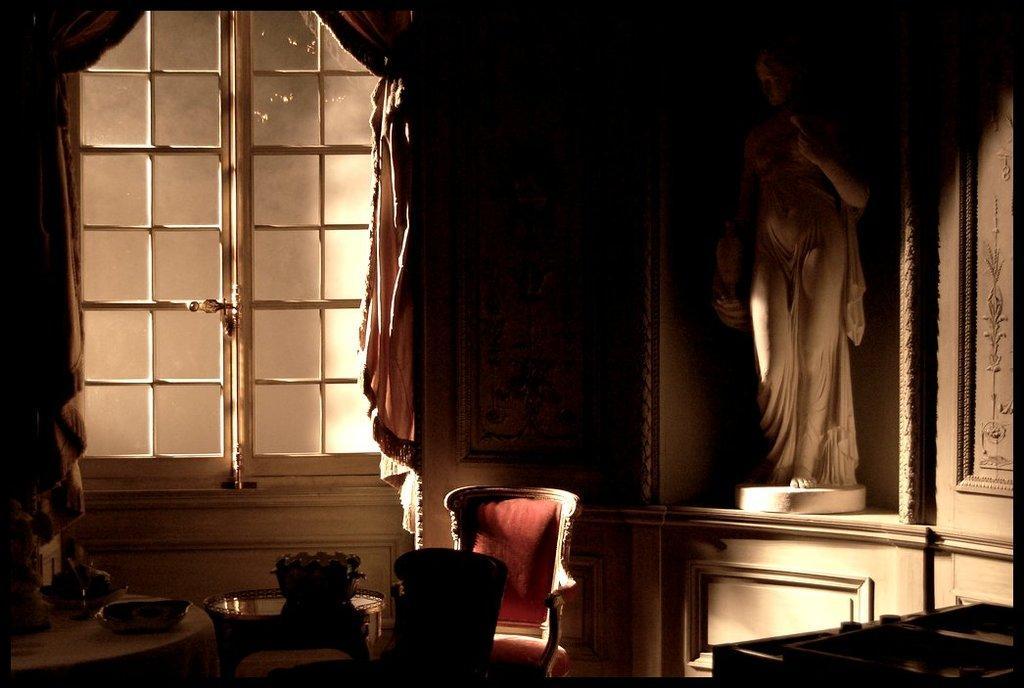Describe this image in one or two sentences. In this picture we can see chairs, tables, bowls, statue, window, curtains and some objects. 